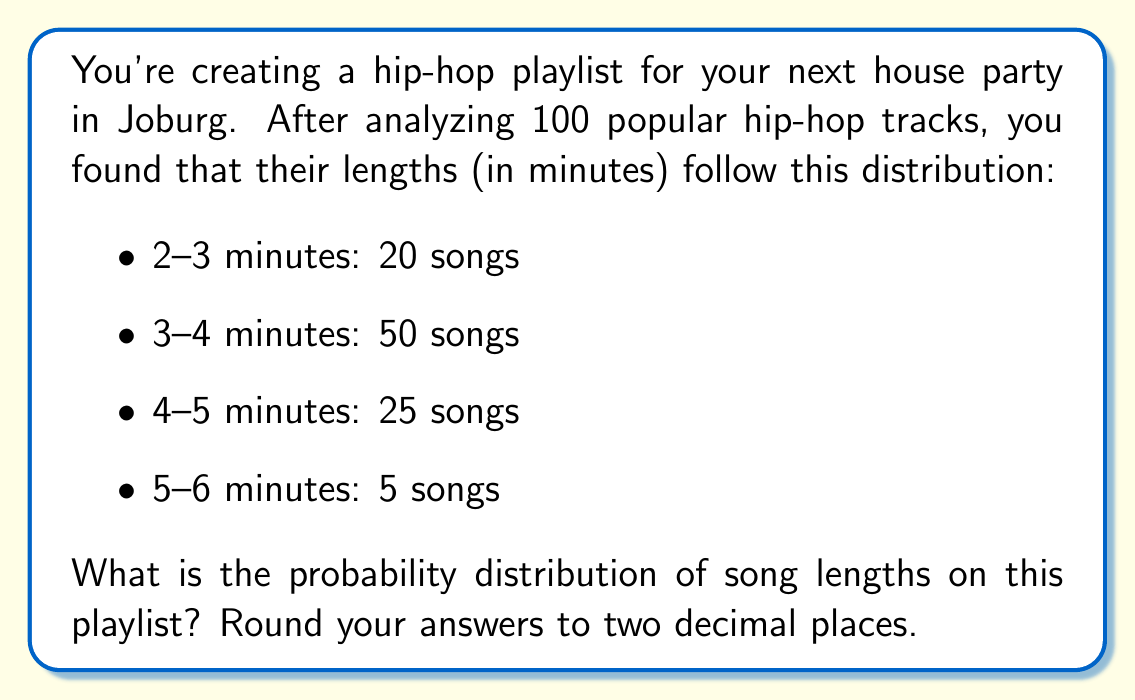Solve this math problem. To compute the probability distribution, we need to calculate the probability for each song length category:

1) First, we need to determine the total number of songs:
   $20 + 50 + 25 + 5 = 100$ songs

2) Now, we calculate the probability for each category:

   For 2-3 minutes:
   $P(2-3) = \frac{20}{100} = 0.20$

   For 3-4 minutes:
   $P(3-4) = \frac{50}{100} = 0.50$

   For 4-5 minutes:
   $P(4-5) = \frac{25}{100} = 0.25$

   For 5-6 minutes:
   $P(5-6) = \frac{5}{100} = 0.05$

3) We can verify that the probabilities sum to 1:
   $0.20 + 0.50 + 0.25 + 0.05 = 1.00$

This gives us the complete probability distribution of song lengths on the playlist.
Answer: $P(2-3) = 0.20$, $P(3-4) = 0.50$, $P(4-5) = 0.25$, $P(5-6) = 0.05$ 